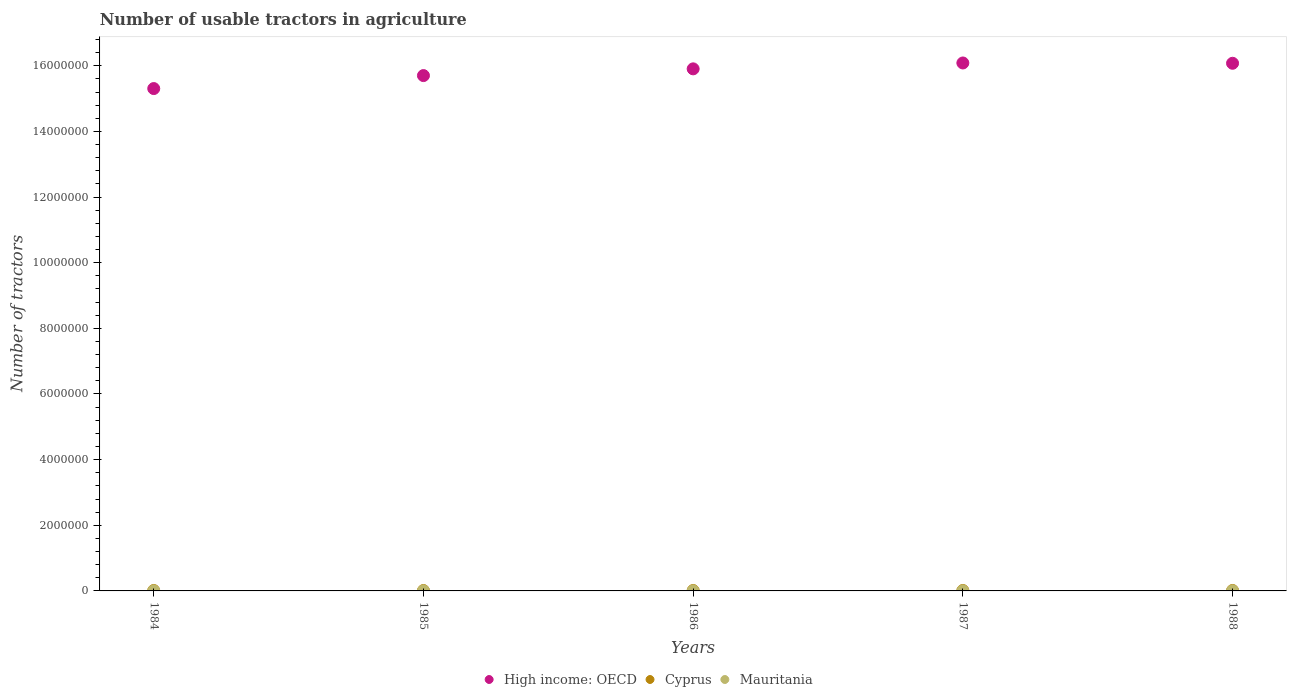How many different coloured dotlines are there?
Give a very brief answer. 3. Is the number of dotlines equal to the number of legend labels?
Offer a very short reply. Yes. What is the number of usable tractors in agriculture in Cyprus in 1987?
Offer a very short reply. 1.31e+04. Across all years, what is the maximum number of usable tractors in agriculture in Cyprus?
Your answer should be very brief. 1.36e+04. Across all years, what is the minimum number of usable tractors in agriculture in High income: OECD?
Keep it short and to the point. 1.53e+07. In which year was the number of usable tractors in agriculture in High income: OECD minimum?
Offer a very short reply. 1984. What is the total number of usable tractors in agriculture in Mauritania in the graph?
Give a very brief answer. 1622. What is the difference between the number of usable tractors in agriculture in High income: OECD in 1984 and that in 1987?
Ensure brevity in your answer.  -7.80e+05. What is the difference between the number of usable tractors in agriculture in High income: OECD in 1986 and the number of usable tractors in agriculture in Cyprus in 1987?
Give a very brief answer. 1.59e+07. What is the average number of usable tractors in agriculture in High income: OECD per year?
Your answer should be very brief. 1.58e+07. In the year 1985, what is the difference between the number of usable tractors in agriculture in Mauritania and number of usable tractors in agriculture in High income: OECD?
Your response must be concise. -1.57e+07. What is the ratio of the number of usable tractors in agriculture in Mauritania in 1984 to that in 1985?
Make the answer very short. 0.97. Is the number of usable tractors in agriculture in Cyprus in 1984 less than that in 1986?
Keep it short and to the point. No. What is the difference between the highest and the lowest number of usable tractors in agriculture in Cyprus?
Provide a short and direct response. 1501. In how many years, is the number of usable tractors in agriculture in Cyprus greater than the average number of usable tractors in agriculture in Cyprus taken over all years?
Make the answer very short. 2. Is it the case that in every year, the sum of the number of usable tractors in agriculture in Mauritania and number of usable tractors in agriculture in High income: OECD  is greater than the number of usable tractors in agriculture in Cyprus?
Offer a terse response. Yes. Does the number of usable tractors in agriculture in Mauritania monotonically increase over the years?
Provide a short and direct response. No. How many years are there in the graph?
Provide a short and direct response. 5. What is the difference between two consecutive major ticks on the Y-axis?
Provide a succinct answer. 2.00e+06. Are the values on the major ticks of Y-axis written in scientific E-notation?
Keep it short and to the point. No. Does the graph contain any zero values?
Make the answer very short. No. Where does the legend appear in the graph?
Provide a succinct answer. Bottom center. What is the title of the graph?
Your answer should be compact. Number of usable tractors in agriculture. Does "Botswana" appear as one of the legend labels in the graph?
Give a very brief answer. No. What is the label or title of the Y-axis?
Provide a succinct answer. Number of tractors. What is the Number of tractors in High income: OECD in 1984?
Make the answer very short. 1.53e+07. What is the Number of tractors in Cyprus in 1984?
Your answer should be compact. 1.28e+04. What is the Number of tractors of Mauritania in 1984?
Make the answer very short. 312. What is the Number of tractors of High income: OECD in 1985?
Your answer should be very brief. 1.57e+07. What is the Number of tractors of Cyprus in 1985?
Offer a terse response. 1.21e+04. What is the Number of tractors of Mauritania in 1985?
Your answer should be very brief. 320. What is the Number of tractors in High income: OECD in 1986?
Provide a short and direct response. 1.59e+07. What is the Number of tractors of Cyprus in 1986?
Offer a terse response. 1.26e+04. What is the Number of tractors in Mauritania in 1986?
Ensure brevity in your answer.  330. What is the Number of tractors in High income: OECD in 1987?
Offer a terse response. 1.61e+07. What is the Number of tractors of Cyprus in 1987?
Your response must be concise. 1.31e+04. What is the Number of tractors of Mauritania in 1987?
Your answer should be compact. 330. What is the Number of tractors of High income: OECD in 1988?
Offer a very short reply. 1.61e+07. What is the Number of tractors in Cyprus in 1988?
Your answer should be compact. 1.36e+04. What is the Number of tractors in Mauritania in 1988?
Your answer should be very brief. 330. Across all years, what is the maximum Number of tractors in High income: OECD?
Provide a short and direct response. 1.61e+07. Across all years, what is the maximum Number of tractors in Cyprus?
Your answer should be very brief. 1.36e+04. Across all years, what is the maximum Number of tractors of Mauritania?
Provide a succinct answer. 330. Across all years, what is the minimum Number of tractors of High income: OECD?
Offer a very short reply. 1.53e+07. Across all years, what is the minimum Number of tractors of Cyprus?
Offer a very short reply. 1.21e+04. Across all years, what is the minimum Number of tractors in Mauritania?
Your answer should be very brief. 312. What is the total Number of tractors in High income: OECD in the graph?
Provide a succinct answer. 7.91e+07. What is the total Number of tractors of Cyprus in the graph?
Your answer should be compact. 6.42e+04. What is the total Number of tractors of Mauritania in the graph?
Your response must be concise. 1622. What is the difference between the Number of tractors in High income: OECD in 1984 and that in 1985?
Ensure brevity in your answer.  -3.95e+05. What is the difference between the Number of tractors in Cyprus in 1984 and that in 1985?
Ensure brevity in your answer.  741. What is the difference between the Number of tractors in High income: OECD in 1984 and that in 1986?
Provide a short and direct response. -6.01e+05. What is the difference between the Number of tractors in Cyprus in 1984 and that in 1986?
Keep it short and to the point. 252. What is the difference between the Number of tractors of High income: OECD in 1984 and that in 1987?
Your answer should be compact. -7.80e+05. What is the difference between the Number of tractors in Cyprus in 1984 and that in 1987?
Give a very brief answer. -260. What is the difference between the Number of tractors in High income: OECD in 1984 and that in 1988?
Keep it short and to the point. -7.71e+05. What is the difference between the Number of tractors of Cyprus in 1984 and that in 1988?
Provide a succinct answer. -760. What is the difference between the Number of tractors in High income: OECD in 1985 and that in 1986?
Your response must be concise. -2.05e+05. What is the difference between the Number of tractors in Cyprus in 1985 and that in 1986?
Your response must be concise. -489. What is the difference between the Number of tractors of High income: OECD in 1985 and that in 1987?
Give a very brief answer. -3.84e+05. What is the difference between the Number of tractors of Cyprus in 1985 and that in 1987?
Give a very brief answer. -1001. What is the difference between the Number of tractors of High income: OECD in 1985 and that in 1988?
Offer a very short reply. -3.75e+05. What is the difference between the Number of tractors of Cyprus in 1985 and that in 1988?
Ensure brevity in your answer.  -1501. What is the difference between the Number of tractors of Mauritania in 1985 and that in 1988?
Provide a succinct answer. -10. What is the difference between the Number of tractors in High income: OECD in 1986 and that in 1987?
Keep it short and to the point. -1.79e+05. What is the difference between the Number of tractors of Cyprus in 1986 and that in 1987?
Offer a terse response. -512. What is the difference between the Number of tractors in Mauritania in 1986 and that in 1987?
Your answer should be compact. 0. What is the difference between the Number of tractors in High income: OECD in 1986 and that in 1988?
Keep it short and to the point. -1.70e+05. What is the difference between the Number of tractors of Cyprus in 1986 and that in 1988?
Make the answer very short. -1012. What is the difference between the Number of tractors in Mauritania in 1986 and that in 1988?
Your answer should be compact. 0. What is the difference between the Number of tractors of High income: OECD in 1987 and that in 1988?
Offer a very short reply. 9136. What is the difference between the Number of tractors of Cyprus in 1987 and that in 1988?
Your response must be concise. -500. What is the difference between the Number of tractors of Mauritania in 1987 and that in 1988?
Provide a short and direct response. 0. What is the difference between the Number of tractors of High income: OECD in 1984 and the Number of tractors of Cyprus in 1985?
Ensure brevity in your answer.  1.53e+07. What is the difference between the Number of tractors of High income: OECD in 1984 and the Number of tractors of Mauritania in 1985?
Keep it short and to the point. 1.53e+07. What is the difference between the Number of tractors in Cyprus in 1984 and the Number of tractors in Mauritania in 1985?
Offer a terse response. 1.25e+04. What is the difference between the Number of tractors of High income: OECD in 1984 and the Number of tractors of Cyprus in 1986?
Your answer should be very brief. 1.53e+07. What is the difference between the Number of tractors in High income: OECD in 1984 and the Number of tractors in Mauritania in 1986?
Provide a succinct answer. 1.53e+07. What is the difference between the Number of tractors in Cyprus in 1984 and the Number of tractors in Mauritania in 1986?
Keep it short and to the point. 1.25e+04. What is the difference between the Number of tractors of High income: OECD in 1984 and the Number of tractors of Cyprus in 1987?
Your answer should be compact. 1.53e+07. What is the difference between the Number of tractors in High income: OECD in 1984 and the Number of tractors in Mauritania in 1987?
Ensure brevity in your answer.  1.53e+07. What is the difference between the Number of tractors in Cyprus in 1984 and the Number of tractors in Mauritania in 1987?
Provide a short and direct response. 1.25e+04. What is the difference between the Number of tractors in High income: OECD in 1984 and the Number of tractors in Cyprus in 1988?
Ensure brevity in your answer.  1.53e+07. What is the difference between the Number of tractors of High income: OECD in 1984 and the Number of tractors of Mauritania in 1988?
Keep it short and to the point. 1.53e+07. What is the difference between the Number of tractors in Cyprus in 1984 and the Number of tractors in Mauritania in 1988?
Make the answer very short. 1.25e+04. What is the difference between the Number of tractors in High income: OECD in 1985 and the Number of tractors in Cyprus in 1986?
Offer a terse response. 1.57e+07. What is the difference between the Number of tractors of High income: OECD in 1985 and the Number of tractors of Mauritania in 1986?
Offer a very short reply. 1.57e+07. What is the difference between the Number of tractors of Cyprus in 1985 and the Number of tractors of Mauritania in 1986?
Make the answer very short. 1.18e+04. What is the difference between the Number of tractors of High income: OECD in 1985 and the Number of tractors of Cyprus in 1987?
Provide a short and direct response. 1.57e+07. What is the difference between the Number of tractors in High income: OECD in 1985 and the Number of tractors in Mauritania in 1987?
Your answer should be compact. 1.57e+07. What is the difference between the Number of tractors in Cyprus in 1985 and the Number of tractors in Mauritania in 1987?
Offer a very short reply. 1.18e+04. What is the difference between the Number of tractors of High income: OECD in 1985 and the Number of tractors of Cyprus in 1988?
Ensure brevity in your answer.  1.57e+07. What is the difference between the Number of tractors of High income: OECD in 1985 and the Number of tractors of Mauritania in 1988?
Your answer should be very brief. 1.57e+07. What is the difference between the Number of tractors in Cyprus in 1985 and the Number of tractors in Mauritania in 1988?
Your answer should be compact. 1.18e+04. What is the difference between the Number of tractors of High income: OECD in 1986 and the Number of tractors of Cyprus in 1987?
Provide a short and direct response. 1.59e+07. What is the difference between the Number of tractors in High income: OECD in 1986 and the Number of tractors in Mauritania in 1987?
Make the answer very short. 1.59e+07. What is the difference between the Number of tractors of Cyprus in 1986 and the Number of tractors of Mauritania in 1987?
Make the answer very short. 1.23e+04. What is the difference between the Number of tractors in High income: OECD in 1986 and the Number of tractors in Cyprus in 1988?
Make the answer very short. 1.59e+07. What is the difference between the Number of tractors of High income: OECD in 1986 and the Number of tractors of Mauritania in 1988?
Ensure brevity in your answer.  1.59e+07. What is the difference between the Number of tractors of Cyprus in 1986 and the Number of tractors of Mauritania in 1988?
Give a very brief answer. 1.23e+04. What is the difference between the Number of tractors of High income: OECD in 1987 and the Number of tractors of Cyprus in 1988?
Your response must be concise. 1.61e+07. What is the difference between the Number of tractors in High income: OECD in 1987 and the Number of tractors in Mauritania in 1988?
Provide a short and direct response. 1.61e+07. What is the difference between the Number of tractors in Cyprus in 1987 and the Number of tractors in Mauritania in 1988?
Your answer should be compact. 1.28e+04. What is the average Number of tractors in High income: OECD per year?
Offer a terse response. 1.58e+07. What is the average Number of tractors of Cyprus per year?
Provide a short and direct response. 1.28e+04. What is the average Number of tractors in Mauritania per year?
Your answer should be very brief. 324.4. In the year 1984, what is the difference between the Number of tractors in High income: OECD and Number of tractors in Cyprus?
Offer a very short reply. 1.53e+07. In the year 1984, what is the difference between the Number of tractors in High income: OECD and Number of tractors in Mauritania?
Your answer should be compact. 1.53e+07. In the year 1984, what is the difference between the Number of tractors of Cyprus and Number of tractors of Mauritania?
Your answer should be very brief. 1.25e+04. In the year 1985, what is the difference between the Number of tractors in High income: OECD and Number of tractors in Cyprus?
Your response must be concise. 1.57e+07. In the year 1985, what is the difference between the Number of tractors of High income: OECD and Number of tractors of Mauritania?
Make the answer very short. 1.57e+07. In the year 1985, what is the difference between the Number of tractors of Cyprus and Number of tractors of Mauritania?
Offer a terse response. 1.18e+04. In the year 1986, what is the difference between the Number of tractors in High income: OECD and Number of tractors in Cyprus?
Offer a very short reply. 1.59e+07. In the year 1986, what is the difference between the Number of tractors of High income: OECD and Number of tractors of Mauritania?
Give a very brief answer. 1.59e+07. In the year 1986, what is the difference between the Number of tractors in Cyprus and Number of tractors in Mauritania?
Your response must be concise. 1.23e+04. In the year 1987, what is the difference between the Number of tractors of High income: OECD and Number of tractors of Cyprus?
Offer a terse response. 1.61e+07. In the year 1987, what is the difference between the Number of tractors in High income: OECD and Number of tractors in Mauritania?
Offer a terse response. 1.61e+07. In the year 1987, what is the difference between the Number of tractors of Cyprus and Number of tractors of Mauritania?
Offer a very short reply. 1.28e+04. In the year 1988, what is the difference between the Number of tractors in High income: OECD and Number of tractors in Cyprus?
Offer a terse response. 1.61e+07. In the year 1988, what is the difference between the Number of tractors in High income: OECD and Number of tractors in Mauritania?
Your response must be concise. 1.61e+07. In the year 1988, what is the difference between the Number of tractors in Cyprus and Number of tractors in Mauritania?
Give a very brief answer. 1.33e+04. What is the ratio of the Number of tractors in High income: OECD in 1984 to that in 1985?
Your answer should be compact. 0.97. What is the ratio of the Number of tractors of Cyprus in 1984 to that in 1985?
Ensure brevity in your answer.  1.06. What is the ratio of the Number of tractors of Mauritania in 1984 to that in 1985?
Your answer should be compact. 0.97. What is the ratio of the Number of tractors of High income: OECD in 1984 to that in 1986?
Ensure brevity in your answer.  0.96. What is the ratio of the Number of tractors of Mauritania in 1984 to that in 1986?
Your answer should be compact. 0.95. What is the ratio of the Number of tractors in High income: OECD in 1984 to that in 1987?
Give a very brief answer. 0.95. What is the ratio of the Number of tractors in Cyprus in 1984 to that in 1987?
Provide a short and direct response. 0.98. What is the ratio of the Number of tractors in Mauritania in 1984 to that in 1987?
Your response must be concise. 0.95. What is the ratio of the Number of tractors of High income: OECD in 1984 to that in 1988?
Give a very brief answer. 0.95. What is the ratio of the Number of tractors of Cyprus in 1984 to that in 1988?
Provide a succinct answer. 0.94. What is the ratio of the Number of tractors of Mauritania in 1984 to that in 1988?
Make the answer very short. 0.95. What is the ratio of the Number of tractors in High income: OECD in 1985 to that in 1986?
Your answer should be compact. 0.99. What is the ratio of the Number of tractors of Cyprus in 1985 to that in 1986?
Your answer should be compact. 0.96. What is the ratio of the Number of tractors in Mauritania in 1985 to that in 1986?
Provide a succinct answer. 0.97. What is the ratio of the Number of tractors in High income: OECD in 1985 to that in 1987?
Make the answer very short. 0.98. What is the ratio of the Number of tractors of Cyprus in 1985 to that in 1987?
Give a very brief answer. 0.92. What is the ratio of the Number of tractors of Mauritania in 1985 to that in 1987?
Offer a very short reply. 0.97. What is the ratio of the Number of tractors of High income: OECD in 1985 to that in 1988?
Provide a succinct answer. 0.98. What is the ratio of the Number of tractors of Cyprus in 1985 to that in 1988?
Your answer should be very brief. 0.89. What is the ratio of the Number of tractors of Mauritania in 1985 to that in 1988?
Ensure brevity in your answer.  0.97. What is the ratio of the Number of tractors in High income: OECD in 1986 to that in 1987?
Your answer should be compact. 0.99. What is the ratio of the Number of tractors in Cyprus in 1986 to that in 1987?
Provide a succinct answer. 0.96. What is the ratio of the Number of tractors in High income: OECD in 1986 to that in 1988?
Offer a very short reply. 0.99. What is the ratio of the Number of tractors in Cyprus in 1986 to that in 1988?
Give a very brief answer. 0.93. What is the ratio of the Number of tractors of Mauritania in 1986 to that in 1988?
Your response must be concise. 1. What is the ratio of the Number of tractors in High income: OECD in 1987 to that in 1988?
Give a very brief answer. 1. What is the ratio of the Number of tractors of Cyprus in 1987 to that in 1988?
Give a very brief answer. 0.96. What is the ratio of the Number of tractors of Mauritania in 1987 to that in 1988?
Provide a short and direct response. 1. What is the difference between the highest and the second highest Number of tractors in High income: OECD?
Offer a terse response. 9136. What is the difference between the highest and the second highest Number of tractors of Mauritania?
Give a very brief answer. 0. What is the difference between the highest and the lowest Number of tractors of High income: OECD?
Provide a succinct answer. 7.80e+05. What is the difference between the highest and the lowest Number of tractors in Cyprus?
Give a very brief answer. 1501. What is the difference between the highest and the lowest Number of tractors in Mauritania?
Offer a terse response. 18. 